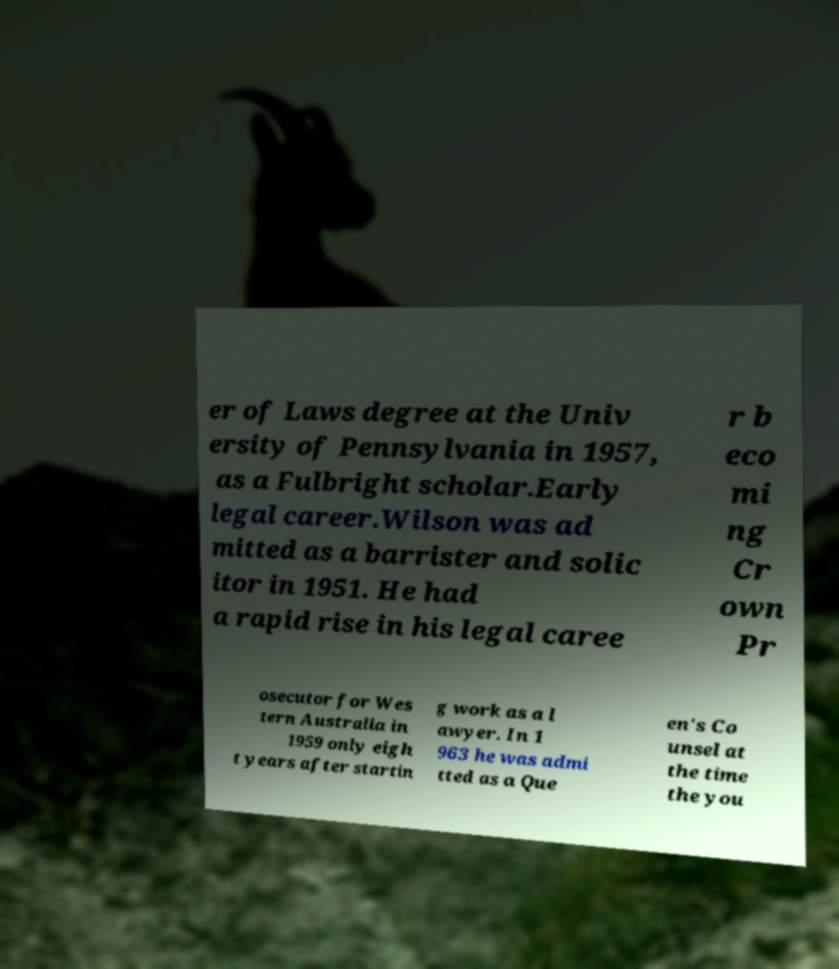Can you accurately transcribe the text from the provided image for me? er of Laws degree at the Univ ersity of Pennsylvania in 1957, as a Fulbright scholar.Early legal career.Wilson was ad mitted as a barrister and solic itor in 1951. He had a rapid rise in his legal caree r b eco mi ng Cr own Pr osecutor for Wes tern Australia in 1959 only eigh t years after startin g work as a l awyer. In 1 963 he was admi tted as a Que en's Co unsel at the time the you 